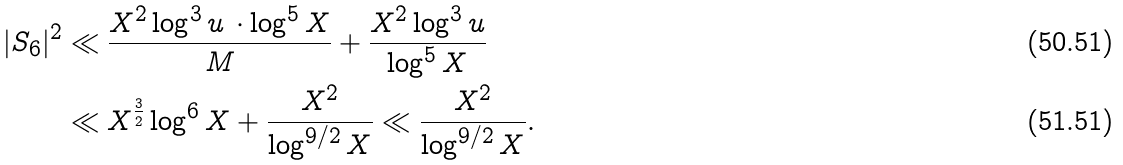<formula> <loc_0><loc_0><loc_500><loc_500>| S _ { 6 } | ^ { 2 } & \ll \frac { X ^ { 2 } \log ^ { 3 } u \, \cdot \log ^ { 5 } X } { M } + \frac { X ^ { 2 } \log ^ { 3 } u } { \log ^ { 5 } X } \\ & \ll X ^ { \frac { 3 } { 2 } } \log ^ { 6 } X + \frac { X ^ { 2 } } { \log ^ { 9 / 2 } X } \ll \frac { X ^ { 2 } } { \log ^ { 9 / 2 } X } .</formula> 